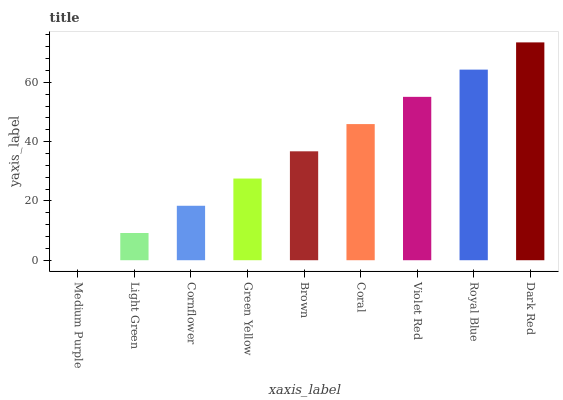Is Medium Purple the minimum?
Answer yes or no. Yes. Is Dark Red the maximum?
Answer yes or no. Yes. Is Light Green the minimum?
Answer yes or no. No. Is Light Green the maximum?
Answer yes or no. No. Is Light Green greater than Medium Purple?
Answer yes or no. Yes. Is Medium Purple less than Light Green?
Answer yes or no. Yes. Is Medium Purple greater than Light Green?
Answer yes or no. No. Is Light Green less than Medium Purple?
Answer yes or no. No. Is Brown the high median?
Answer yes or no. Yes. Is Brown the low median?
Answer yes or no. Yes. Is Dark Red the high median?
Answer yes or no. No. Is Royal Blue the low median?
Answer yes or no. No. 